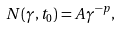<formula> <loc_0><loc_0><loc_500><loc_500>N ( \gamma , t _ { 0 } ) = A \gamma ^ { - p } ,</formula> 